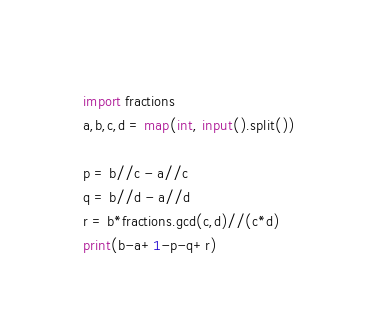<code> <loc_0><loc_0><loc_500><loc_500><_Python_>import fractions
a,b,c,d = map(int, input().split())

p = b//c - a//c
q = b//d - a//d
r = b*fractions.gcd(c,d)//(c*d)
print(b-a+1-p-q+r)</code> 